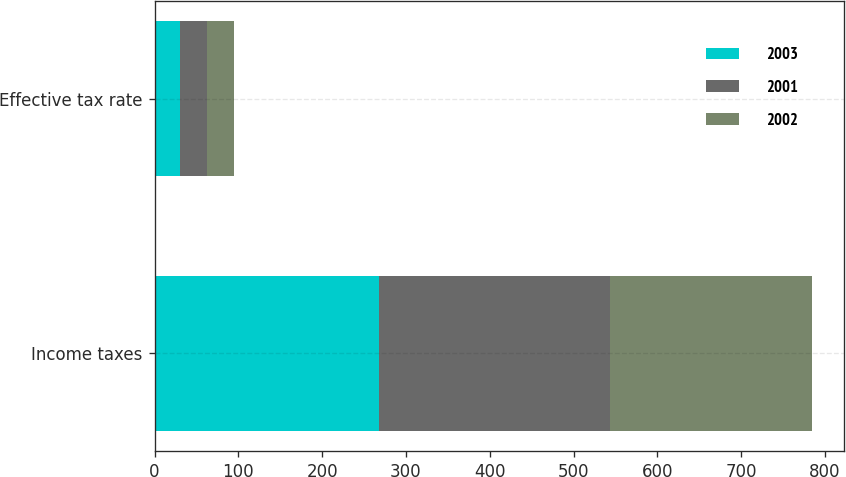Convert chart. <chart><loc_0><loc_0><loc_500><loc_500><stacked_bar_chart><ecel><fcel>Income taxes<fcel>Effective tax rate<nl><fcel>2003<fcel>268<fcel>30.2<nl><fcel>2001<fcel>275<fcel>32.1<nl><fcel>2002<fcel>241<fcel>32.8<nl></chart> 